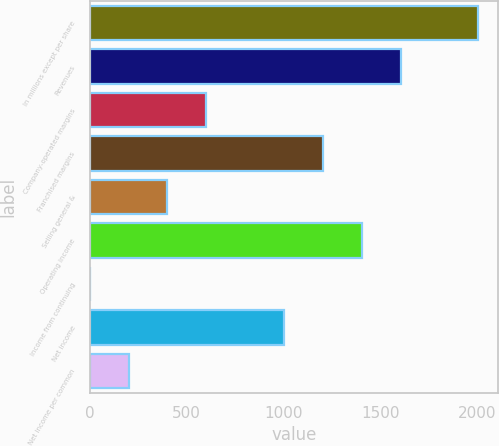Convert chart. <chart><loc_0><loc_0><loc_500><loc_500><bar_chart><fcel>In millions except per share<fcel>Revenues<fcel>Company-operated margins<fcel>Franchised margins<fcel>Selling general &<fcel>Operating income<fcel>Income from continuing<fcel>Net income<fcel>Net income per common<nl><fcel>2007<fcel>1605.64<fcel>602.19<fcel>1204.26<fcel>401.5<fcel>1404.95<fcel>0.12<fcel>1003.57<fcel>200.81<nl></chart> 